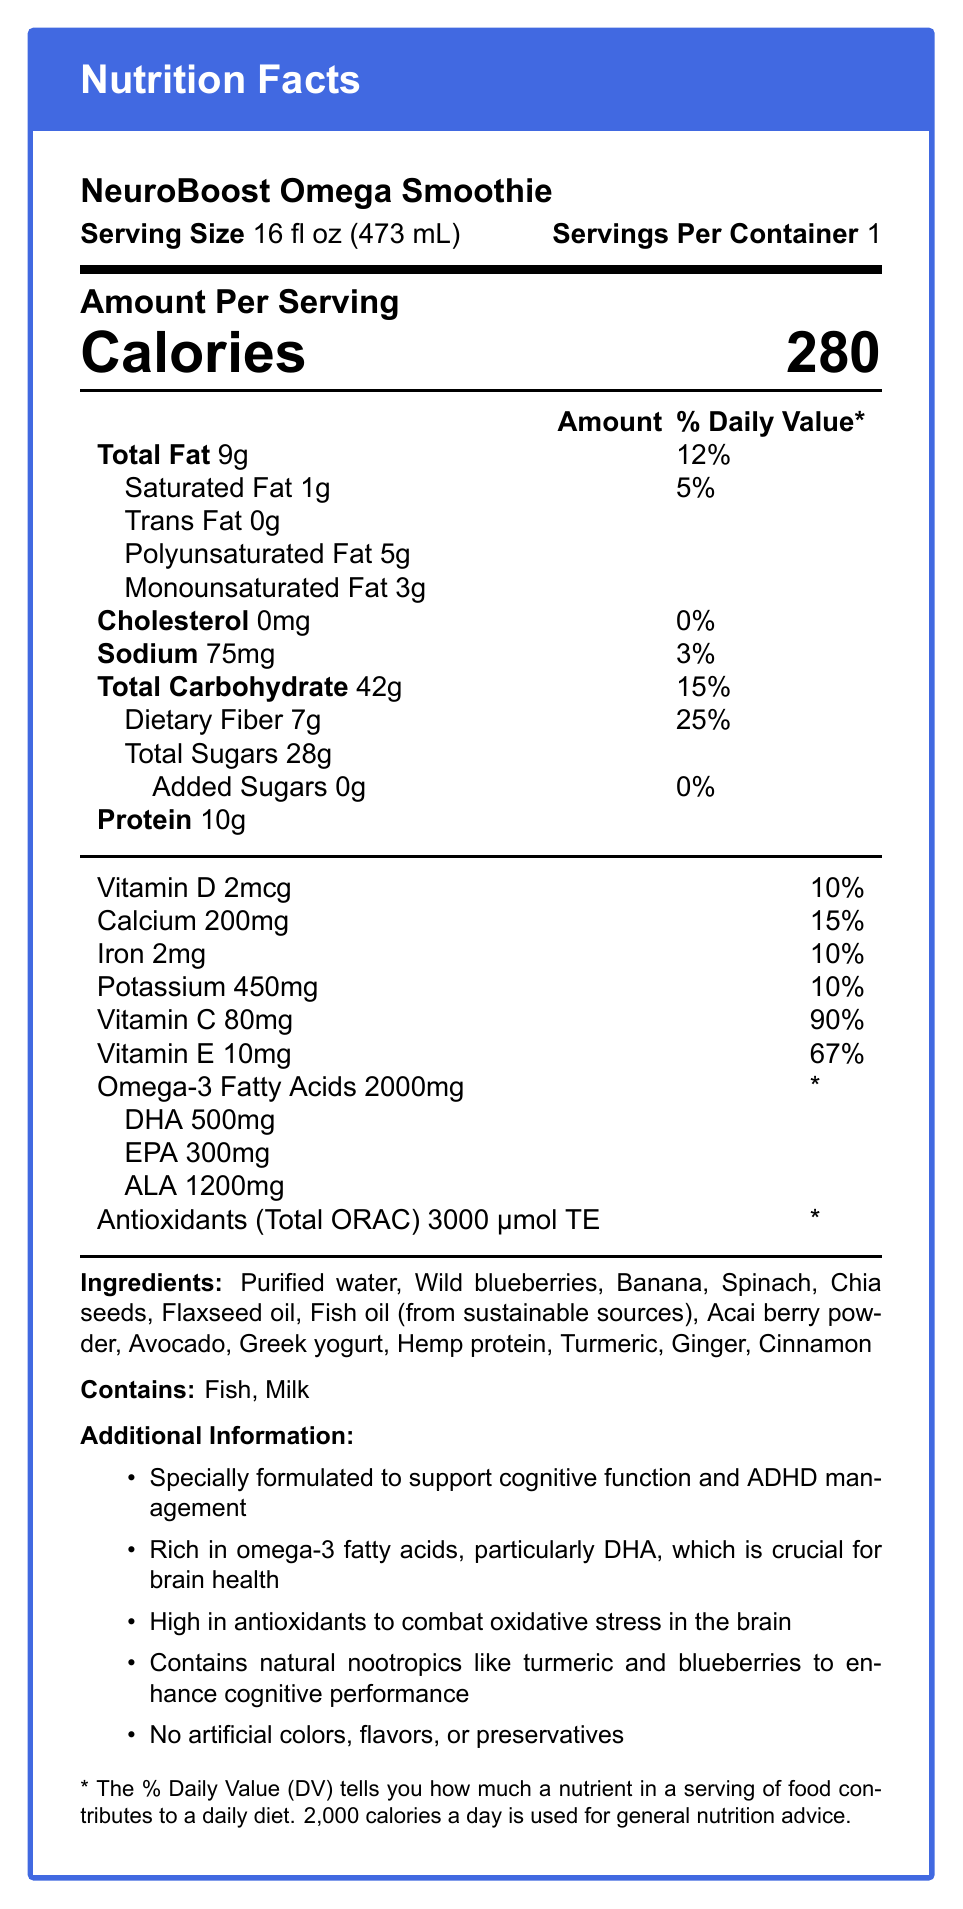what is the serving size of the NeuroBoost Omega Smoothie? The serving size is clearly listed at the top of the Nutrition Facts section of the document.
Answer: 16 fl oz (473 mL) how many calories are in one serving? The document shows the number of calories in the section titled "Amount Per Serving."
Answer: 280 calories what is the daily value percentage for dietary fiber? The daily value percentage for dietary fiber is listed in the Total Carbohydrate section of the document.
Answer: 25% how much Omega-3 fatty acids does the NeuroBoost Omega Smoothie contain? The amount of Omega-3 fatty acids is shown towards the bottom in the nutrient section.
Answer: 2000mg what ingredients are in this smoothie? The ingredients are listed towards the bottom of the document under the Ingredients section.
Answer: Purified water, Wild blueberries, Banana, Spinach, Chia seeds, Flaxseed oil, Fish oil (from sustainable sources), Acai berry powder, Avocado, Greek yogurt, Hemp protein, Turmeric, Ginger, Cinnamon what are the possible allergens present in this smoothie? The Allergen Information section at the bottom of the document lists Fish and Milk.
Answer: Fish and Milk Does this smoothie contain any added sugars? The document lists "Added Sugars" as 0g in the Total Carbohydrate section.
Answer: No, it contains 0g of added sugars. which vitamin contributes the most to the daily value percentage? A. Vitamin D B. Calcium C. Vitamin C D. Iron Vitamin C has the highest daily value contribution at 90%.
Answer: C which of the following fats is highest in the NeuroBoost Omega Smoothie? I. Saturated Fat II. Polyunsaturated Fat III. Monounsaturated Fat Polyunsaturated Fat is the highest at 5g.
Answer: II does the smoothie contain artificial colors, flavors, or preservatives? The additional information section states that the smoothie has no artificial colors, flavors, or preservatives.
Answer: No summarize the main features of the NeuroBoost Omega Smoothie as described in the document. The summary captures all the key points from serving size, nutrient content, functional claims, ingredient list, and allergen information provided in the document.
Answer: The NeuroBoost Omega Smoothie is a 16 fl oz drink designed to support cognitive function and ADHD management. It contains 280 calories per serving and is rich in omega-3 fatty acids and antioxidants. It provides significant amounts of dietary fiber, protein, and various essential vitamins and minerals. The ingredients include natural nootropics and are free from artificial additives. It has fish and milk allergens. how much DHA is in the smoothie? The document lists DHA as 500mg under the Omega-3 Fatty Acids section.
Answer: 500mg how much Vitamin E is present as a percentage of daily value? The daily value percentage for Vitamin E is listed as 67% in the vitamin section.
Answer: 67% what is the total fat content as a percentage of daily value? The document lists the daily value percentage for total fat as 12%.
Answer: 12% how much total carbohydrate is in the smoothie? The amount of total carbohydrate is listed in the Total Carbohydrate section near the middle of the document.
Answer: 42g is the smoothie high in sodium compared to daily recommendations? (considering daily recommendation is around 2400mg) The sodium content is listed as 75mg and 3% of the daily value, which is relatively low compared to the daily recommendation.
Answer: No, it only contains 75mg, which is around 3% of the daily value. what is the ORAC value of the antioxidants in the smoothie? The antioxidant section lists the ORAC value as 3000 μmol TE.
Answer: 3000 μmol TE what is the sugar source in this smoothie? The document lists total sugars but does not identify the specific source within the ingredients.
Answer: The document does not specify the exact source of sugars. is the NeuroBoost Omega Smoothie specially formulated for brain health? The additional information section states that it is specially formulated to support cognitive function and ADHD management.
Answer: Yes 